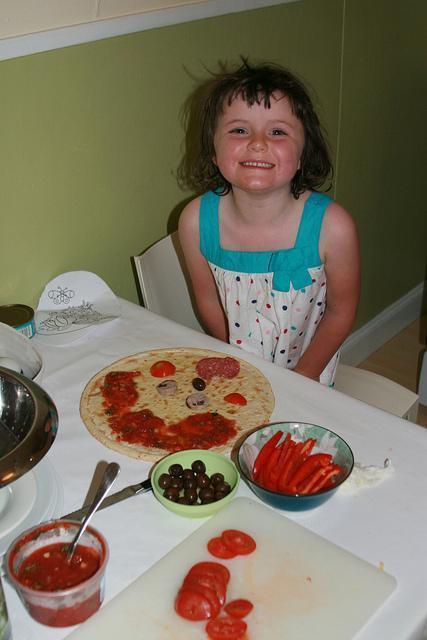Is the caption "The pizza is touching the dining table." a true representation of the image?
Answer yes or no. Yes. Is the caption "The person is behind the dining table." a true representation of the image?
Answer yes or no. Yes. 